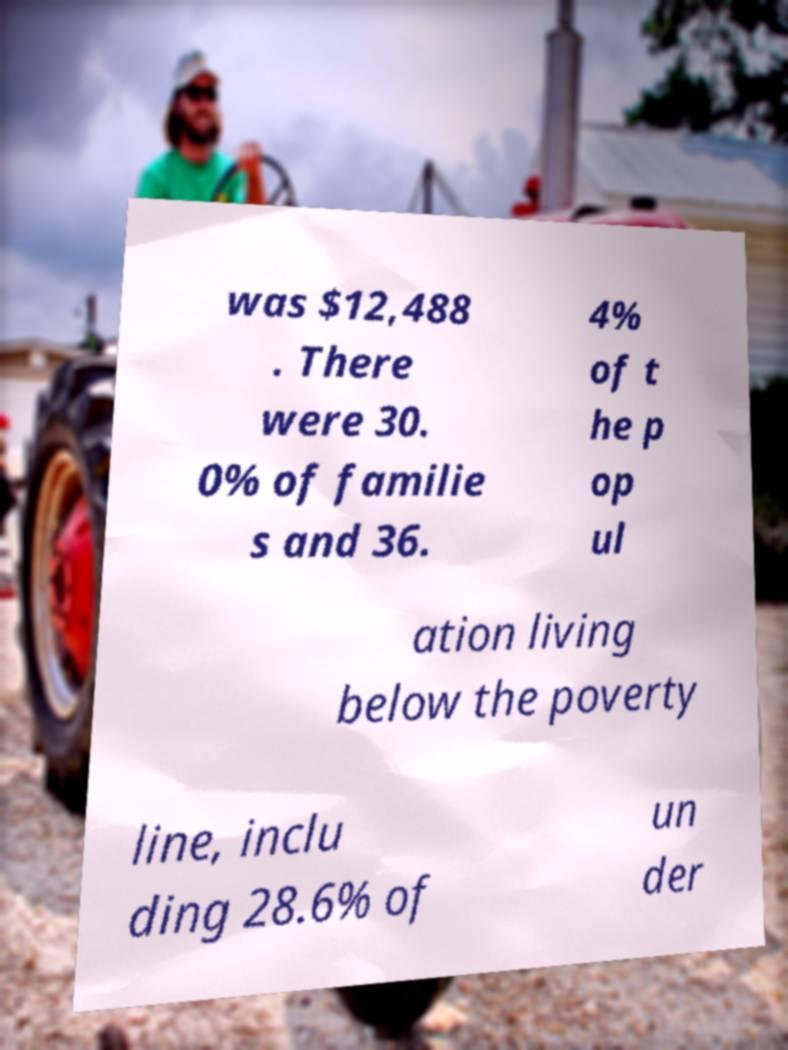There's text embedded in this image that I need extracted. Can you transcribe it verbatim? was $12,488 . There were 30. 0% of familie s and 36. 4% of t he p op ul ation living below the poverty line, inclu ding 28.6% of un der 